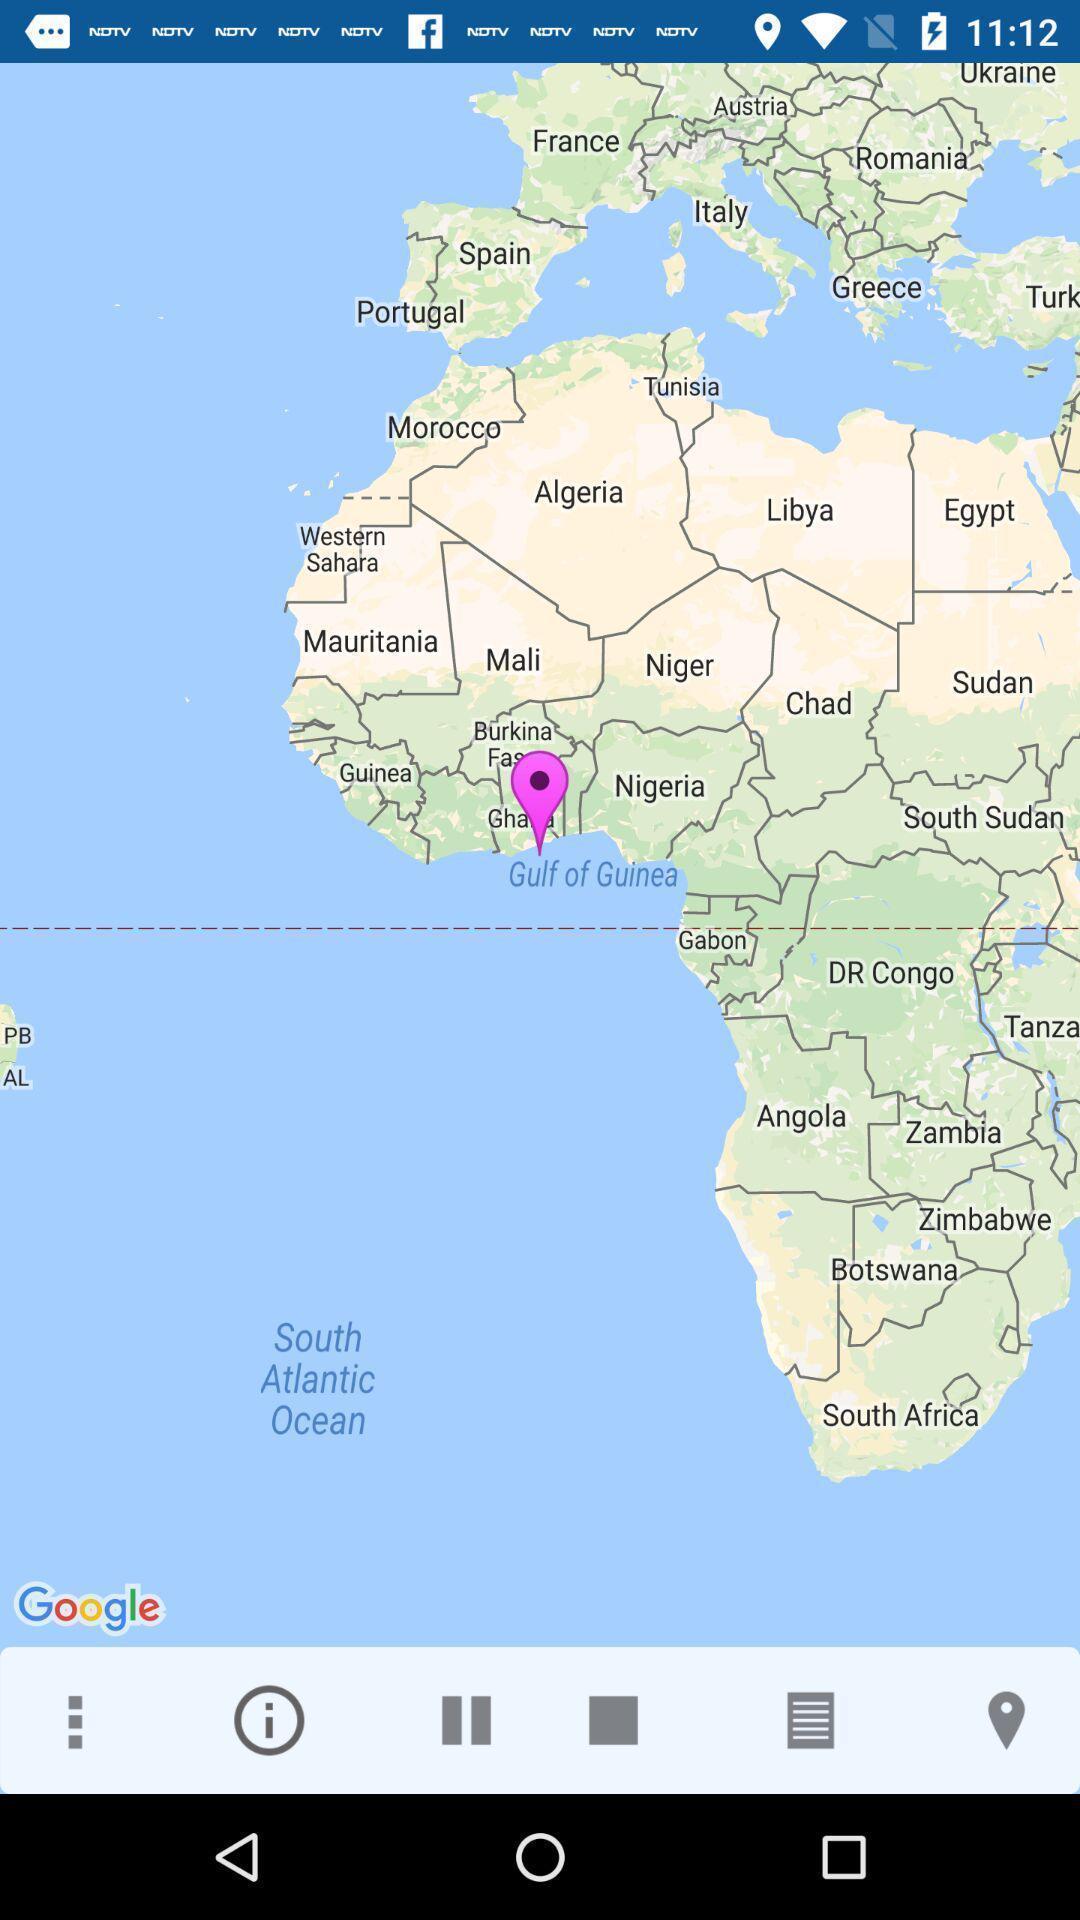What can you discern from this picture? Page showing the location with pin in maps. 